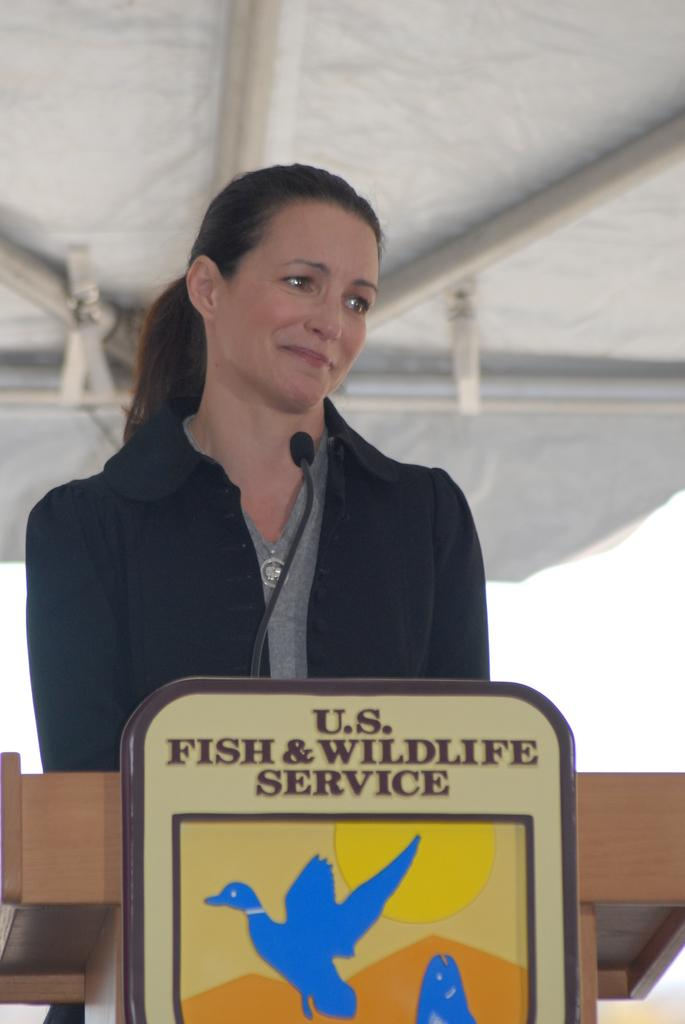<image>
Render a clear and concise summary of the photo. A woman standing behind a podium with a fish and wildlife service logo in front. 